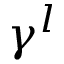Convert formula to latex. <formula><loc_0><loc_0><loc_500><loc_500>\gamma ^ { l }</formula> 